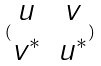<formula> <loc_0><loc_0><loc_500><loc_500>( \begin{matrix} u & v \\ v ^ { * } & u ^ { * } \end{matrix} )</formula> 